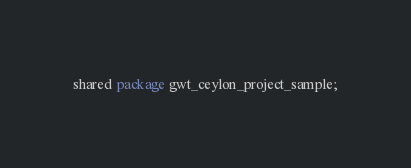<code> <loc_0><loc_0><loc_500><loc_500><_Ceylon_>shared package gwt_ceylon_project_sample;
</code> 